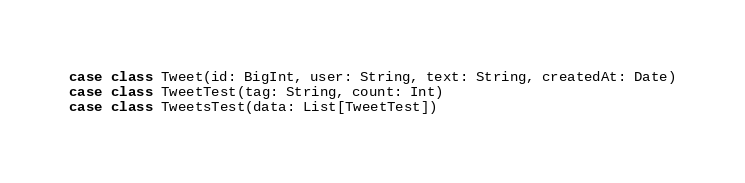Convert code to text. <code><loc_0><loc_0><loc_500><loc_500><_Scala_>case class Tweet(id: BigInt, user: String, text: String, createdAt: Date)
case class TweetTest(tag: String, count: Int)
case class TweetsTest(data: List[TweetTest])</code> 